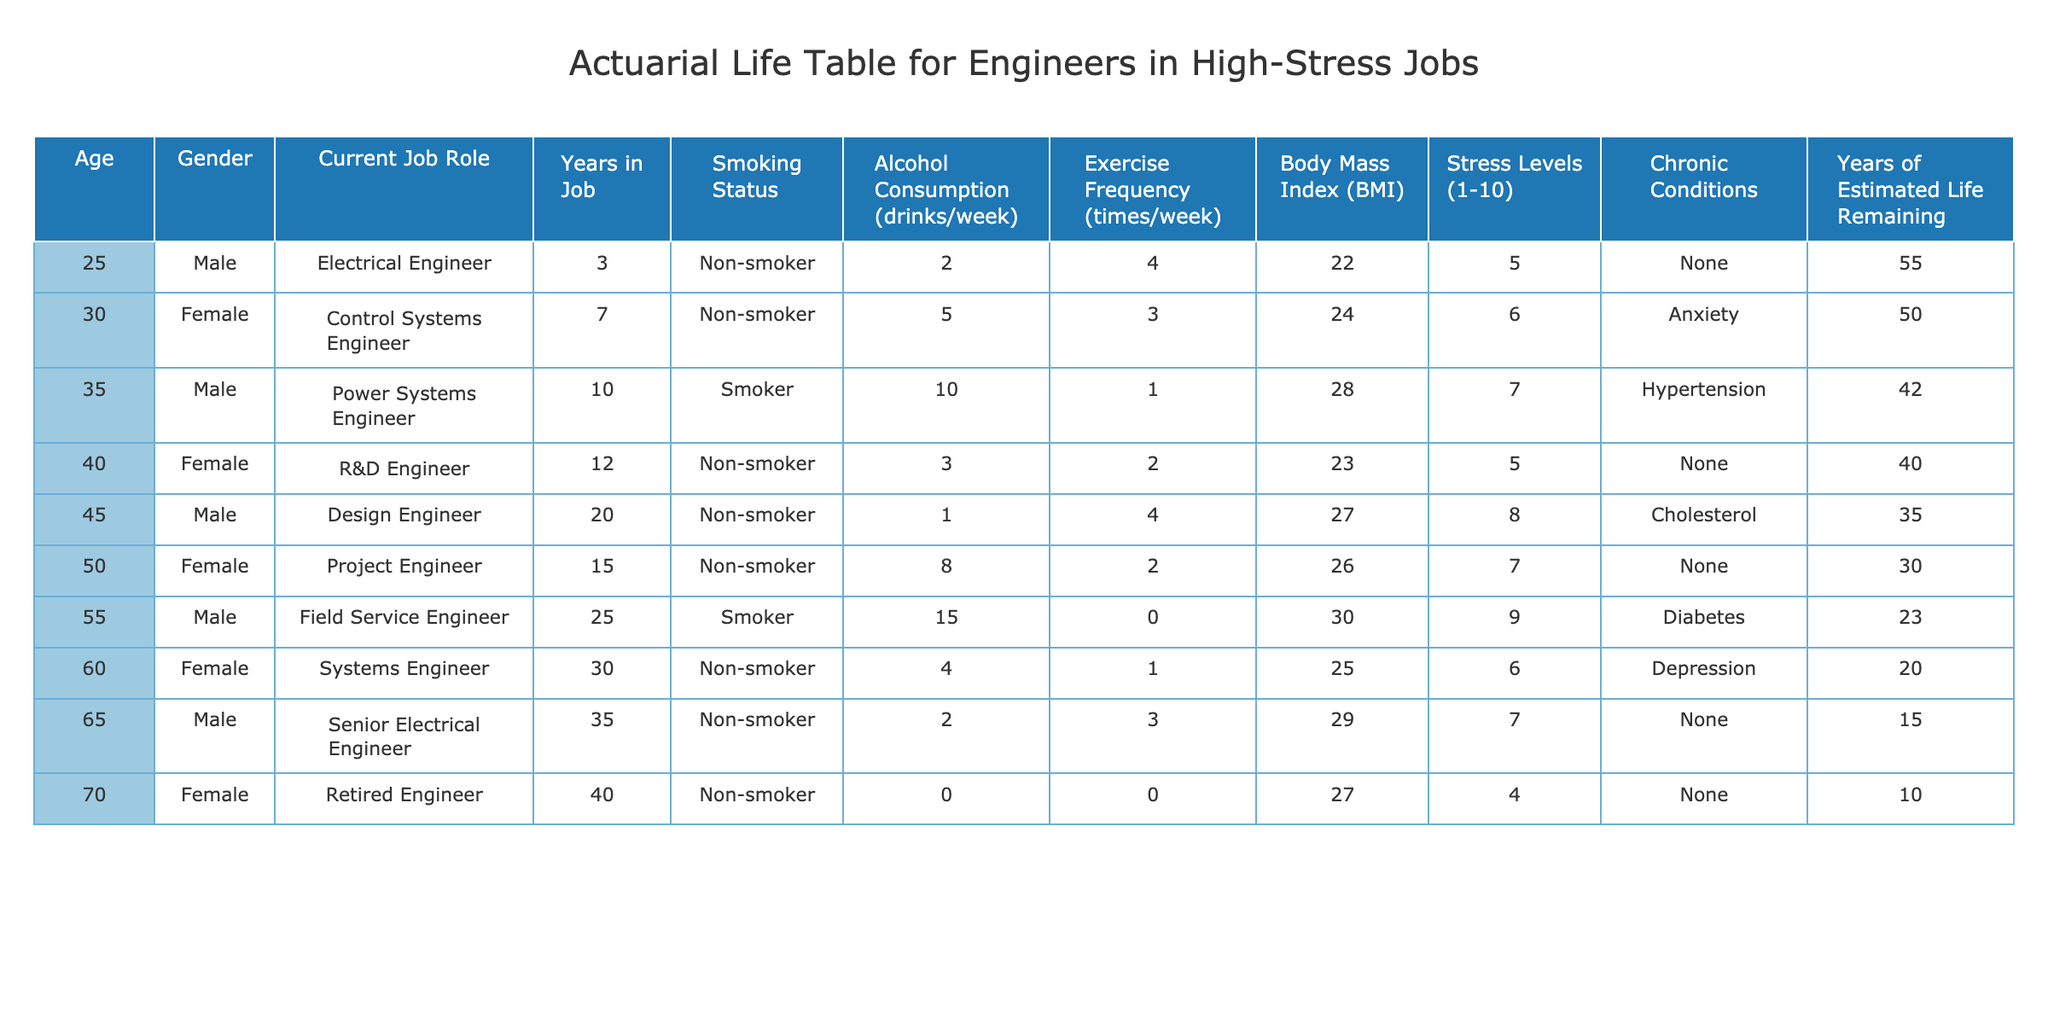What is the smoking status of the 40-year-old female engineer? The 40-year-old female engineer, who works as an R&D Engineer, has a smoking status marked as "Non-smoker." This information can be directly found in the respective row of the table concerning her profile.
Answer: Non-smoker What is the average Body Mass Index (BMI) of the engineers in the table? The BMI values for the engineers are: 22, 24, 28, 23, 27, 26, 30, 25, 29, 27. To calculate the average, sum these values (22 + 24 + 28 + 23 + 27 + 26 + 30 + 25 + 29 + 27) =  25.5. There are 10 engineers, so the average BMI = 255 / 10 = 25.5.
Answer: 25.5 Do any of the engineers have chronic conditions? Yes, some of the engineers have chronic conditions noted in the table. Specifically, the 30-year-old female has anxiety, the 35-year-old male has hypertension, the 45-year-old male has cholesterol issues, the 55-year-old male has diabetes, and the 60-year-old female has depression. The presence of these conditions indicates multiple engineers are affected by health issues.
Answer: Yes Which engineer has the highest stress level? The engineer with the highest stress level is the 55-year-old male Field Service Engineer, who has a stress level rated at 9. This is the highest value in the "Stress Levels" column of the table, and by scanning through the values, it's evident that no other engineer surpasses this score.
Answer: 55-year-old male Field Service Engineer What is the relationship between age and years of estimated life remaining in the table? To analyze this relationship, we observe the ages and corresponding years of estimated life remaining: (25, 55), (30, 50), (35, 42), (40, 40), (45, 35), (50, 30), (55, 23), (60, 20), (65, 15), (70, 10). It shows a trend of decreasing years of estimated life remaining as age increases. This indicates a negative correlation where older ages correspond to fewer estimated remaining years.
Answer: Negative correlation How many years of job experience does the youngest engineer have compared to the oldest engineer? The youngest engineer is 25 years old with 3 years of job experience, while the oldest engineer at 70 years has 40 years of job experience. To find the difference in experience, subtract the younger's experience from the older's: 40 - 3 = 37. Therefore, the oldest engineer has 37 more years of job experience.
Answer: 37 years 